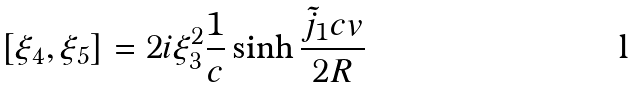Convert formula to latex. <formula><loc_0><loc_0><loc_500><loc_500>[ \xi _ { 4 } , \xi _ { 5 } ] = 2 i \xi _ { 3 } ^ { 2 } { \frac { 1 } { c } } \sinh { \frac { \tilde { j } _ { 1 } c v } { 2 R } }</formula> 